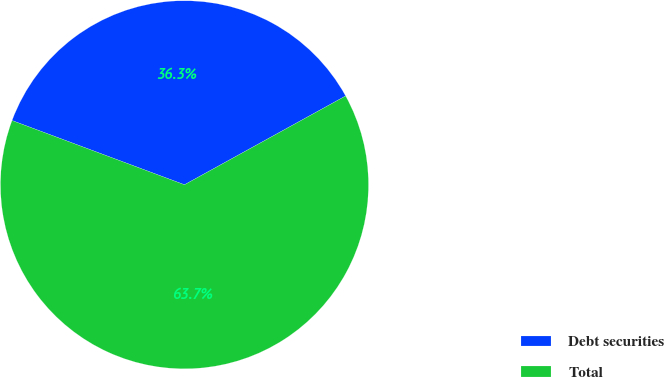<chart> <loc_0><loc_0><loc_500><loc_500><pie_chart><fcel>Debt securities<fcel>Total<nl><fcel>36.31%<fcel>63.69%<nl></chart> 